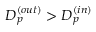Convert formula to latex. <formula><loc_0><loc_0><loc_500><loc_500>D _ { p } ^ { ( o u t ) } > D _ { p } ^ { ( i n ) }</formula> 